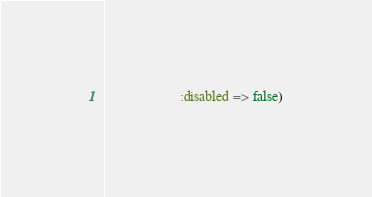<code> <loc_0><loc_0><loc_500><loc_500><_Ruby_>                     :disabled => false)</code> 